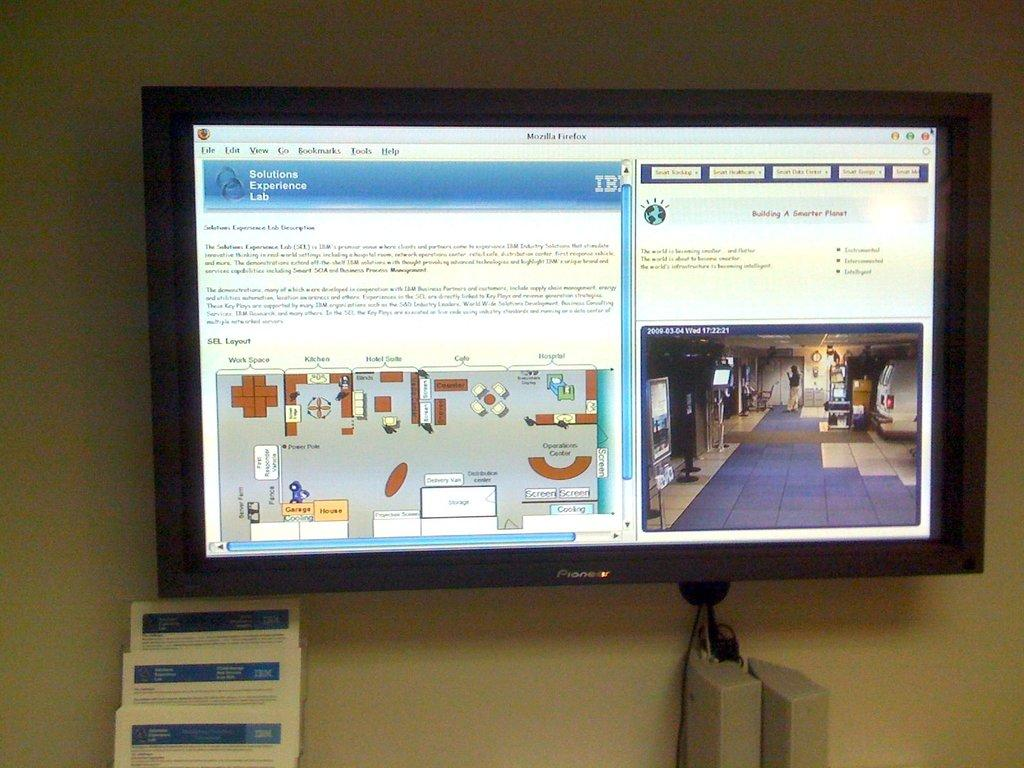<image>
Share a concise interpretation of the image provided. a solutions experience lab that is on a computer screen 